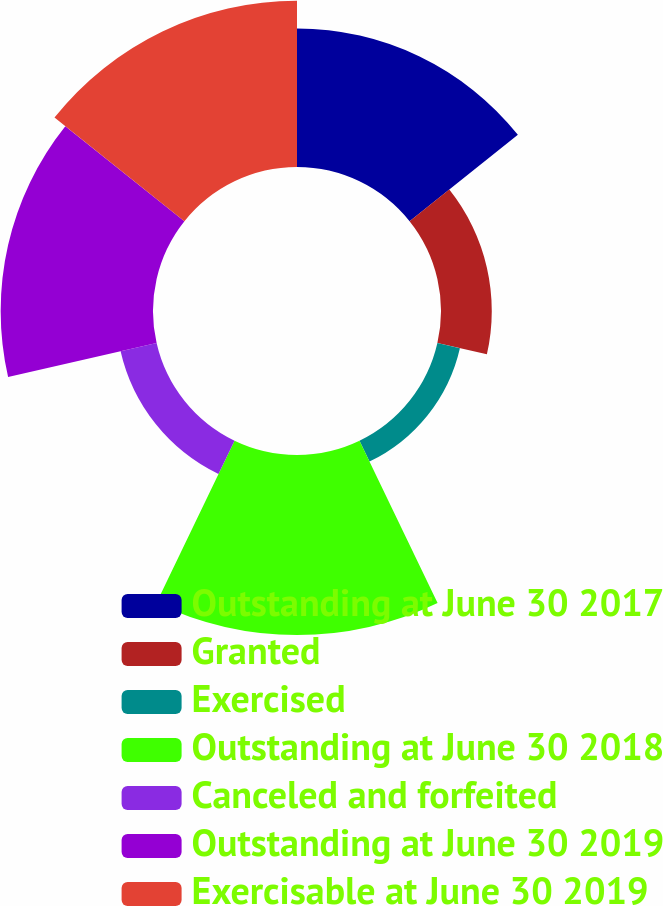<chart> <loc_0><loc_0><loc_500><loc_500><pie_chart><fcel>Outstanding at June 30 2017<fcel>Granted<fcel>Exercised<fcel>Outstanding at June 30 2018<fcel>Canceled and forfeited<fcel>Outstanding at June 30 2019<fcel>Exercisable at June 30 2019<nl><fcel>18.52%<fcel>6.79%<fcel>3.09%<fcel>24.07%<fcel>4.94%<fcel>20.37%<fcel>22.22%<nl></chart> 